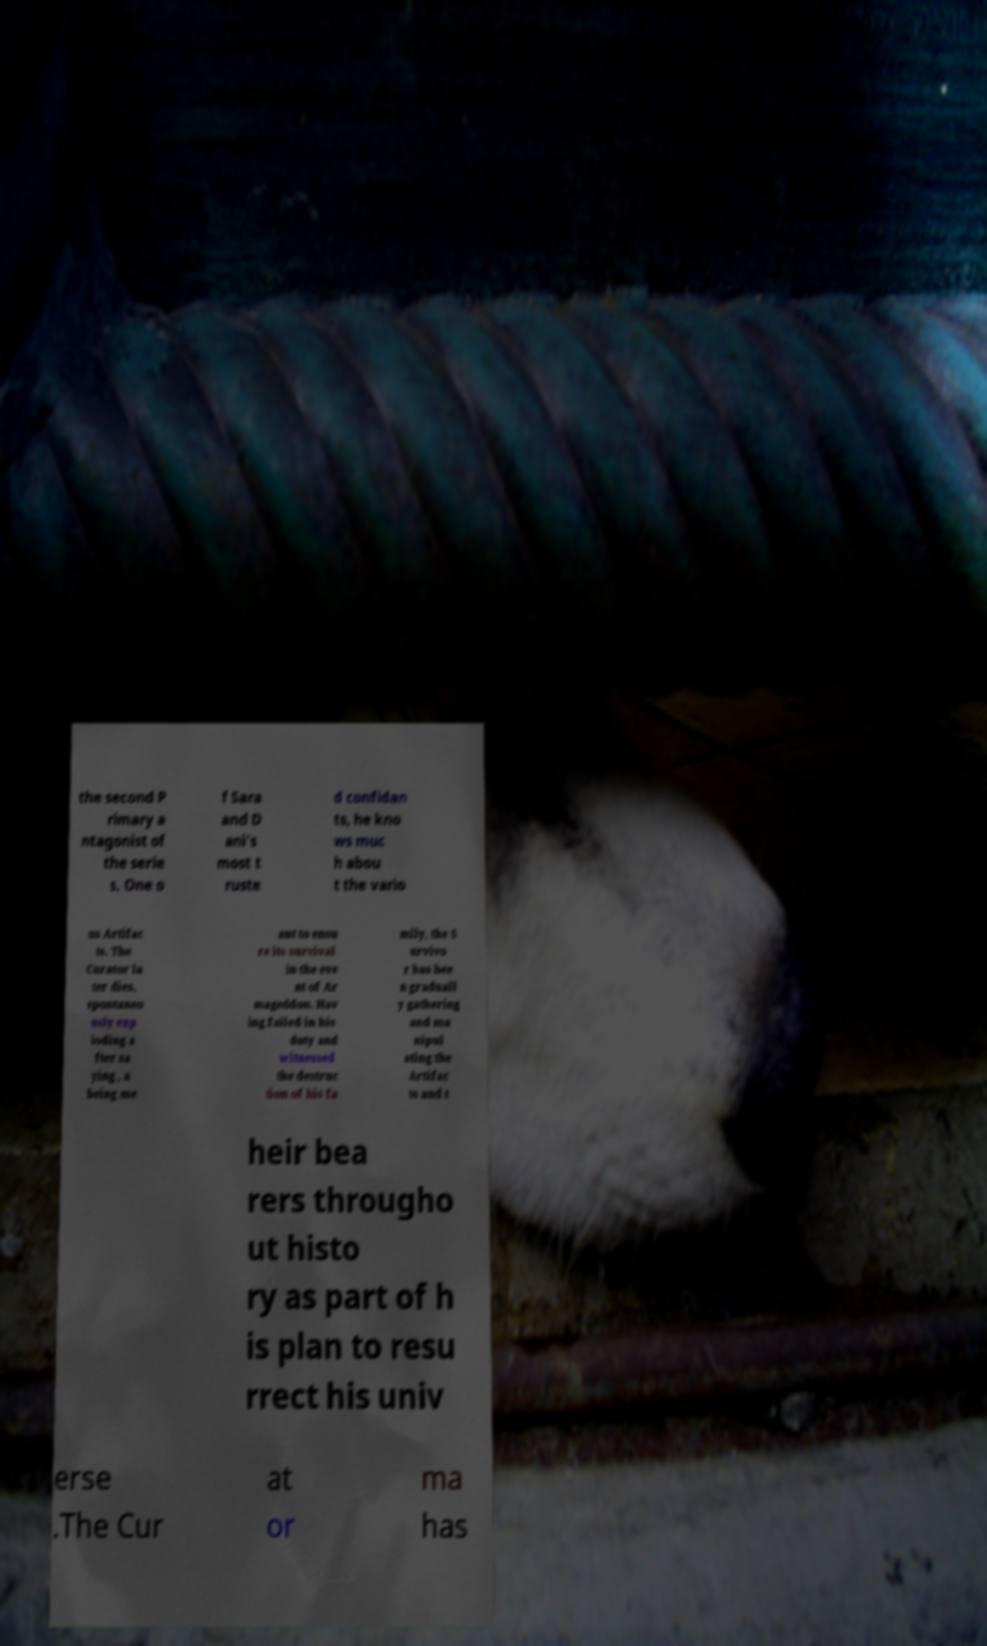What messages or text are displayed in this image? I need them in a readable, typed format. the second P rimary a ntagonist of the serie s. One o f Sara and D ani's most t ruste d confidan ts, he kno ws muc h abou t the vario us Artifac ts. The Curator la ter dies, spontaneo usly exp loding a fter sa ying , a being me ant to ensu re its survival in the eve nt of Ar mageddon. Hav ing failed in his duty and witnessed the destruc tion of his fa mily, the S urvivo r has bee n graduall y gathering and ma nipul ating the Artifac ts and t heir bea rers througho ut histo ry as part of h is plan to resu rrect his univ erse .The Cur at or ma has 